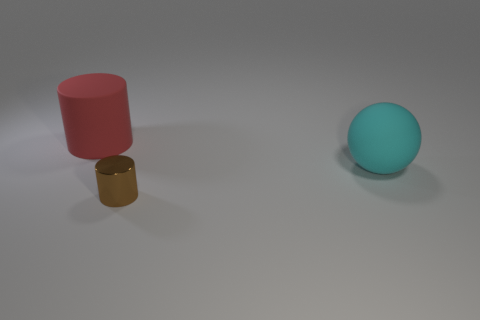Are there any other things that have the same material as the tiny cylinder?
Provide a succinct answer. No. What material is the big object that is behind the matte ball in front of the red thing made of?
Your answer should be very brief. Rubber. Are there any other things that have the same size as the brown cylinder?
Offer a terse response. No. Is the material of the large ball the same as the object that is in front of the cyan sphere?
Ensure brevity in your answer.  No. What material is the object that is both to the left of the large cyan matte thing and behind the tiny metallic thing?
Ensure brevity in your answer.  Rubber. What color is the large matte object that is left of the matte object that is to the right of the red matte thing?
Keep it short and to the point. Red. What is the material of the thing that is to the left of the small brown shiny cylinder?
Provide a succinct answer. Rubber. Are there fewer big spheres than gray matte cylinders?
Give a very brief answer. No. There is a small thing; is its shape the same as the matte thing that is to the left of the small thing?
Give a very brief answer. Yes. There is a object that is behind the tiny metallic thing and on the left side of the large matte ball; what shape is it?
Offer a terse response. Cylinder. 